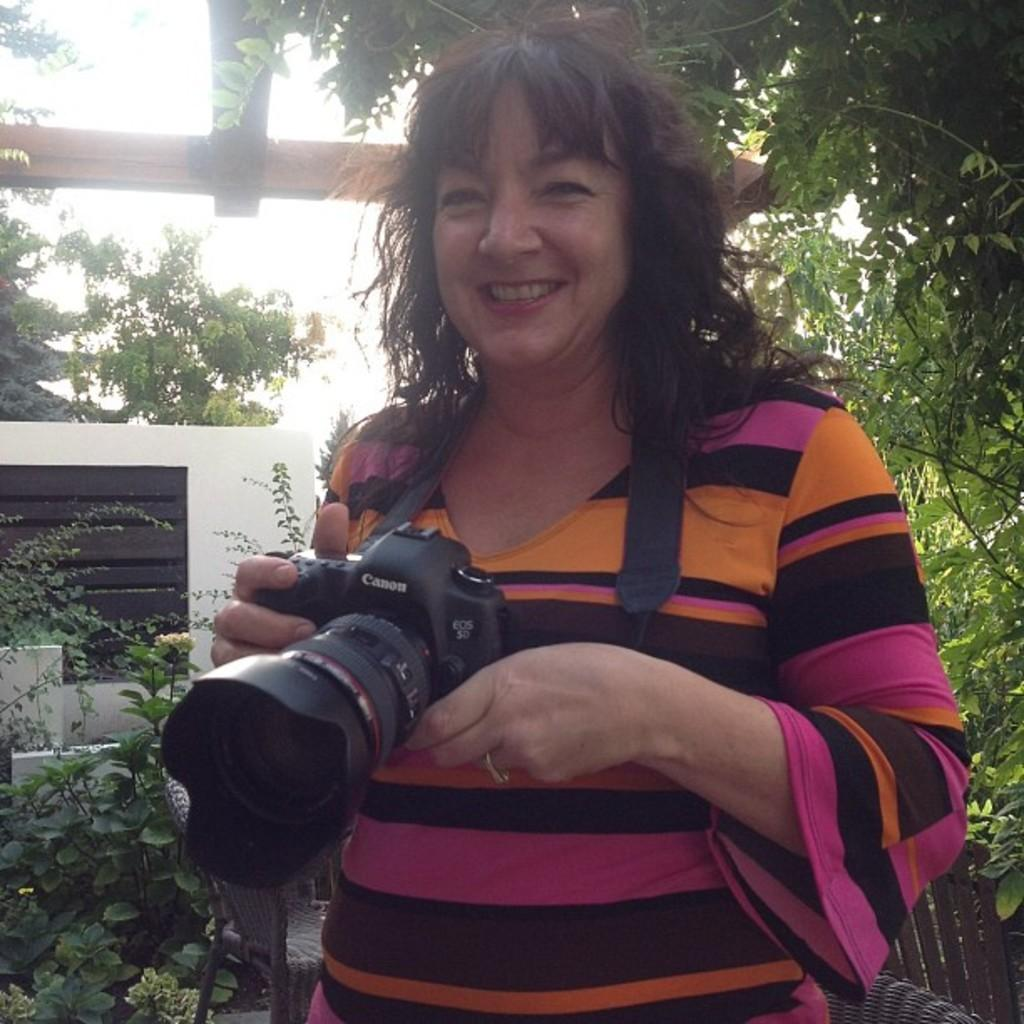Who is the main subject in the image? There is a woman in the image. What is the woman holding in her hands? The woman is holding a camera in her hands. What can be seen in the background of the image? There is a wall, plants, trees, and the sky visible in the background of the image. What type of guitar can be seen in the woman's hair in the image? There is no guitar present in the image, nor is there any mention of the woman's hair. 